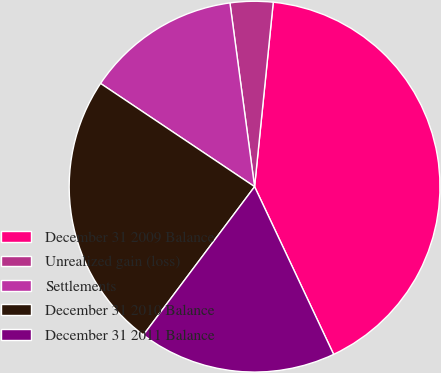Convert chart. <chart><loc_0><loc_0><loc_500><loc_500><pie_chart><fcel>December 31 2009 Balance<fcel>Unrealized gain (loss)<fcel>Settlements<fcel>December 31 2010 Balance<fcel>December 31 2011 Balance<nl><fcel>41.38%<fcel>3.73%<fcel>13.48%<fcel>24.16%<fcel>17.25%<nl></chart> 